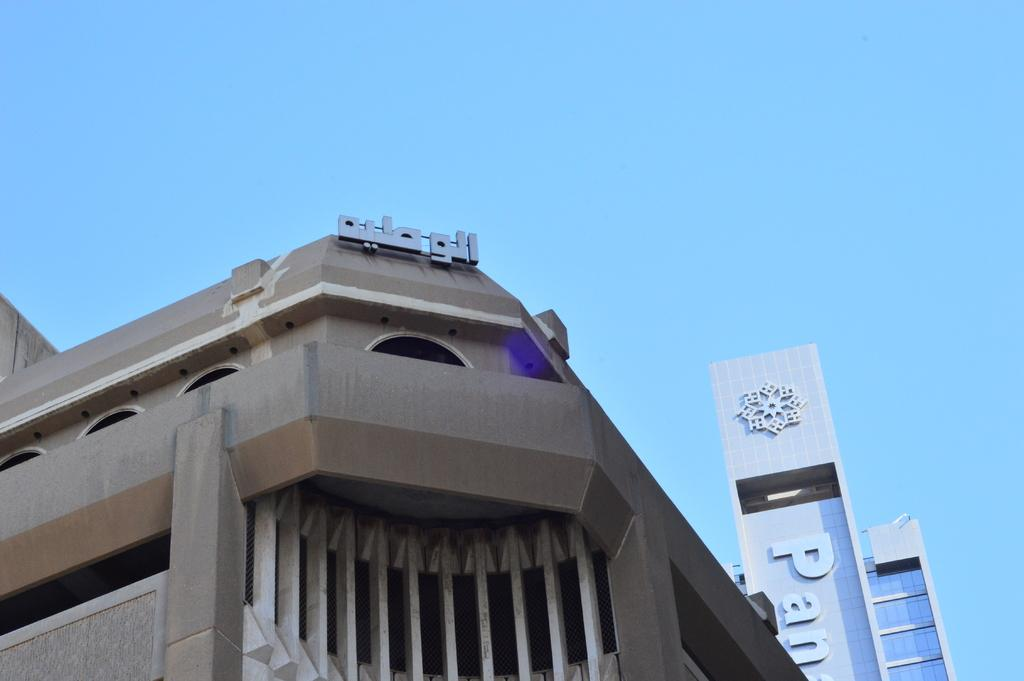What type of structures can be seen in the image? There are buildings in the image. Are there any specific details on the buildings? Yes, there are names on some of the buildings. What can be seen in the background of the image? The sky is visible in the background of the image. What type of engine can be seen powering the buildings in the image? There is no engine present in the image, as buildings do not require engines to function. 